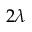<formula> <loc_0><loc_0><loc_500><loc_500>2 \lambda</formula> 